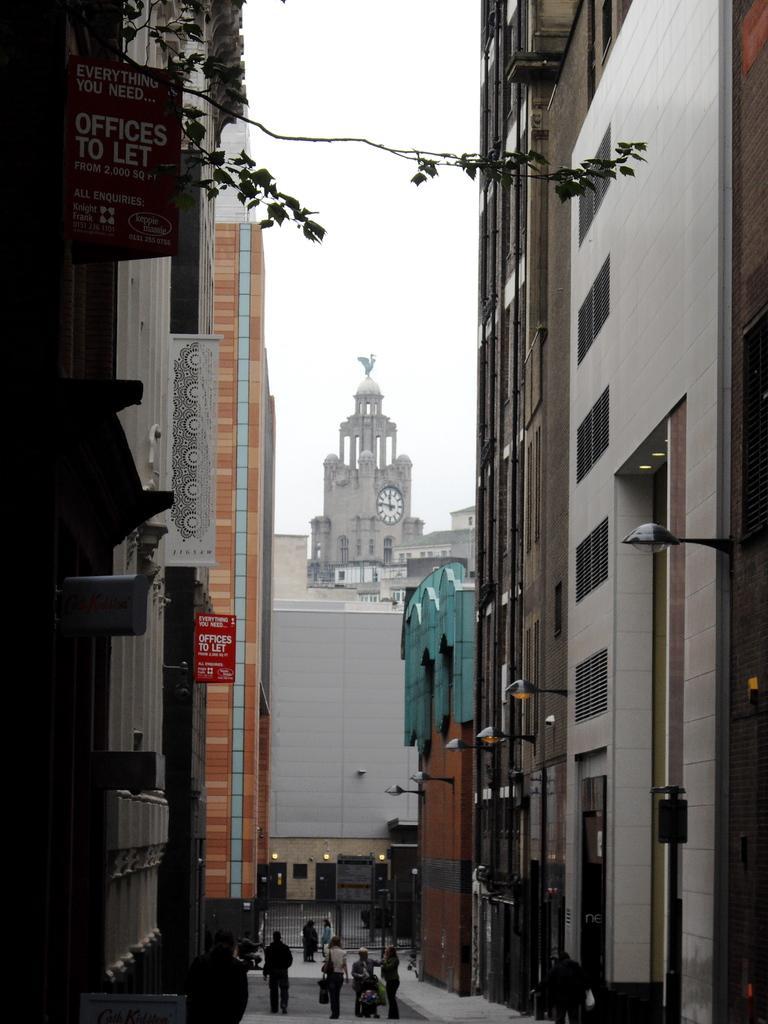Describe this image in one or two sentences. At the bottom of the image we can see persons on the road. On the right side of the image we can see lights and buildings. On the left side of the image we can see tree and buildings. In the background we can see clock tower, buildings and sky. 